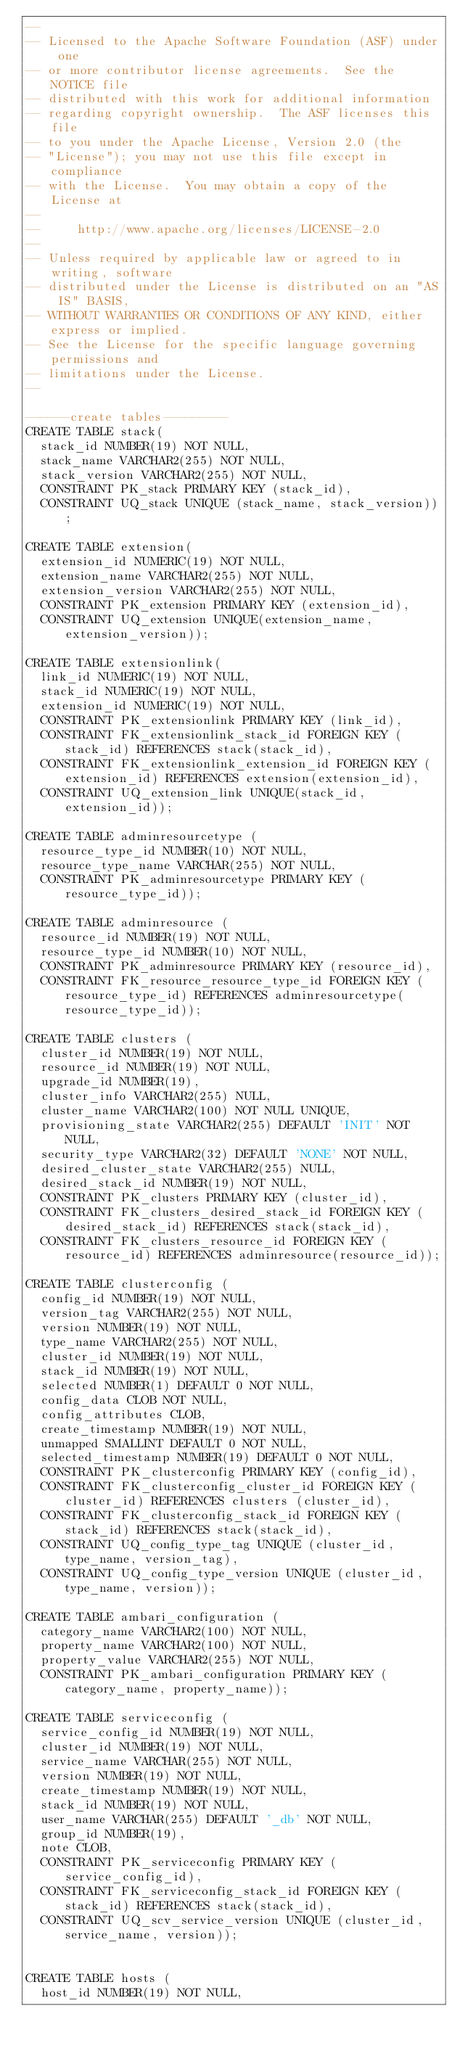Convert code to text. <code><loc_0><loc_0><loc_500><loc_500><_SQL_>--
-- Licensed to the Apache Software Foundation (ASF) under one
-- or more contributor license agreements.  See the NOTICE file
-- distributed with this work for additional information
-- regarding copyright ownership.  The ASF licenses this file
-- to you under the Apache License, Version 2.0 (the
-- "License"); you may not use this file except in compliance
-- with the License.  You may obtain a copy of the License at
--
--     http://www.apache.org/licenses/LICENSE-2.0
--
-- Unless required by applicable law or agreed to in writing, software
-- distributed under the License is distributed on an "AS IS" BASIS,
-- WITHOUT WARRANTIES OR CONDITIONS OF ANY KIND, either express or implied.
-- See the License for the specific language governing permissions and
-- limitations under the License.
--

------create tables---------
CREATE TABLE stack(
  stack_id NUMBER(19) NOT NULL,
  stack_name VARCHAR2(255) NOT NULL,
  stack_version VARCHAR2(255) NOT NULL,
  CONSTRAINT PK_stack PRIMARY KEY (stack_id),
  CONSTRAINT UQ_stack UNIQUE (stack_name, stack_version));

CREATE TABLE extension(
  extension_id NUMERIC(19) NOT NULL,
  extension_name VARCHAR2(255) NOT NULL,
  extension_version VARCHAR2(255) NOT NULL,
  CONSTRAINT PK_extension PRIMARY KEY (extension_id),
  CONSTRAINT UQ_extension UNIQUE(extension_name, extension_version));

CREATE TABLE extensionlink(
  link_id NUMERIC(19) NOT NULL,
  stack_id NUMERIC(19) NOT NULL,
  extension_id NUMERIC(19) NOT NULL,
  CONSTRAINT PK_extensionlink PRIMARY KEY (link_id),
  CONSTRAINT FK_extensionlink_stack_id FOREIGN KEY (stack_id) REFERENCES stack(stack_id),
  CONSTRAINT FK_extensionlink_extension_id FOREIGN KEY (extension_id) REFERENCES extension(extension_id),
  CONSTRAINT UQ_extension_link UNIQUE(stack_id, extension_id));

CREATE TABLE adminresourcetype (
  resource_type_id NUMBER(10) NOT NULL,
  resource_type_name VARCHAR(255) NOT NULL,
  CONSTRAINT PK_adminresourcetype PRIMARY KEY (resource_type_id));

CREATE TABLE adminresource (
  resource_id NUMBER(19) NOT NULL,
  resource_type_id NUMBER(10) NOT NULL,
  CONSTRAINT PK_adminresource PRIMARY KEY (resource_id),
  CONSTRAINT FK_resource_resource_type_id FOREIGN KEY (resource_type_id) REFERENCES adminresourcetype(resource_type_id));

CREATE TABLE clusters (
  cluster_id NUMBER(19) NOT NULL,
  resource_id NUMBER(19) NOT NULL,
  upgrade_id NUMBER(19),
  cluster_info VARCHAR2(255) NULL,
  cluster_name VARCHAR2(100) NOT NULL UNIQUE,
  provisioning_state VARCHAR2(255) DEFAULT 'INIT' NOT NULL,
  security_type VARCHAR2(32) DEFAULT 'NONE' NOT NULL,
  desired_cluster_state VARCHAR2(255) NULL,
  desired_stack_id NUMBER(19) NOT NULL,
  CONSTRAINT PK_clusters PRIMARY KEY (cluster_id),
  CONSTRAINT FK_clusters_desired_stack_id FOREIGN KEY (desired_stack_id) REFERENCES stack(stack_id),
  CONSTRAINT FK_clusters_resource_id FOREIGN KEY (resource_id) REFERENCES adminresource(resource_id));

CREATE TABLE clusterconfig (
  config_id NUMBER(19) NOT NULL,
  version_tag VARCHAR2(255) NOT NULL,
  version NUMBER(19) NOT NULL,
  type_name VARCHAR2(255) NOT NULL,
  cluster_id NUMBER(19) NOT NULL,
  stack_id NUMBER(19) NOT NULL,
  selected NUMBER(1) DEFAULT 0 NOT NULL,
  config_data CLOB NOT NULL,
  config_attributes CLOB,
  create_timestamp NUMBER(19) NOT NULL,
  unmapped SMALLINT DEFAULT 0 NOT NULL,
  selected_timestamp NUMBER(19) DEFAULT 0 NOT NULL,
  CONSTRAINT PK_clusterconfig PRIMARY KEY (config_id),
  CONSTRAINT FK_clusterconfig_cluster_id FOREIGN KEY (cluster_id) REFERENCES clusters (cluster_id),
  CONSTRAINT FK_clusterconfig_stack_id FOREIGN KEY (stack_id) REFERENCES stack(stack_id),
  CONSTRAINT UQ_config_type_tag UNIQUE (cluster_id, type_name, version_tag),
  CONSTRAINT UQ_config_type_version UNIQUE (cluster_id, type_name, version));

CREATE TABLE ambari_configuration (
  category_name VARCHAR2(100) NOT NULL,
  property_name VARCHAR2(100) NOT NULL,
  property_value VARCHAR2(255) NOT NULL,
  CONSTRAINT PK_ambari_configuration PRIMARY KEY (category_name, property_name));

CREATE TABLE serviceconfig (
  service_config_id NUMBER(19) NOT NULL,
  cluster_id NUMBER(19) NOT NULL,
  service_name VARCHAR(255) NOT NULL,
  version NUMBER(19) NOT NULL,
  create_timestamp NUMBER(19) NOT NULL,
  stack_id NUMBER(19) NOT NULL,
  user_name VARCHAR(255) DEFAULT '_db' NOT NULL,
  group_id NUMBER(19),
  note CLOB,
  CONSTRAINT PK_serviceconfig PRIMARY KEY (service_config_id),
  CONSTRAINT FK_serviceconfig_stack_id FOREIGN KEY (stack_id) REFERENCES stack(stack_id),
  CONSTRAINT UQ_scv_service_version UNIQUE (cluster_id, service_name, version));


CREATE TABLE hosts (
  host_id NUMBER(19) NOT NULL,</code> 